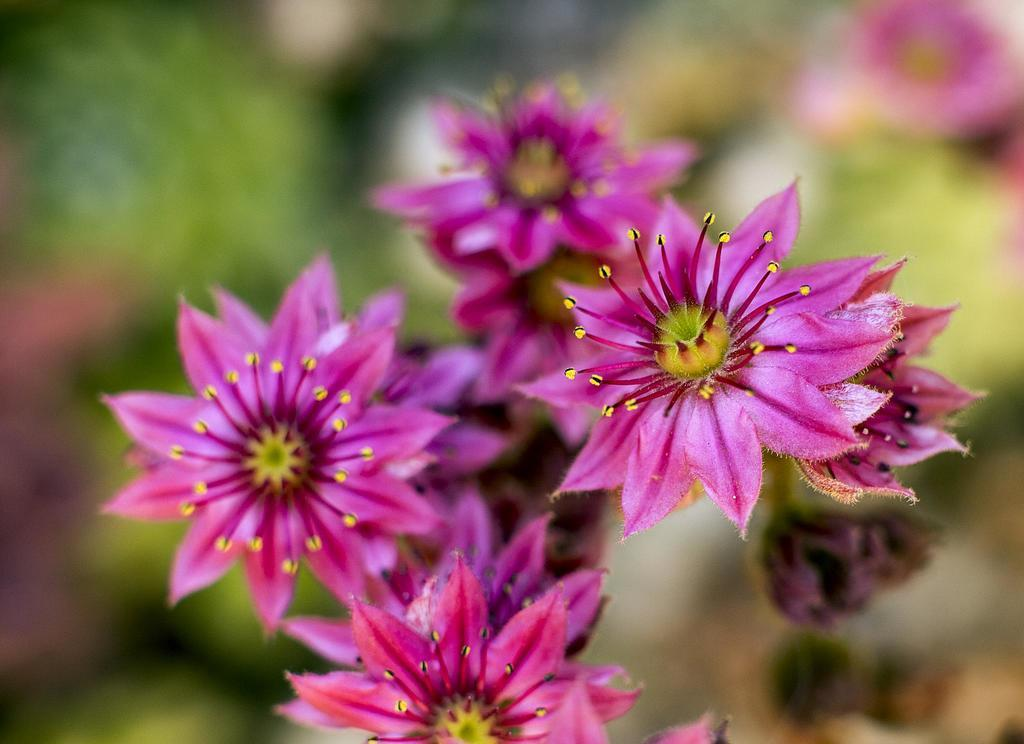What type of flowers can be seen in the image? There are pink color flowers in the image. Can you describe the background of the image? The background of the image is blurred. What type of wrist accessory is visible on the flowers in the image? There is no wrist accessory present on the flowers in the image. What mode of transport can be seen in the image? There is no mode of transport present in the image; it only features pink color flowers and a blurred background. 